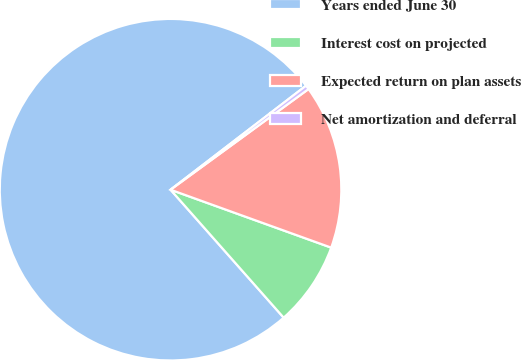Convert chart. <chart><loc_0><loc_0><loc_500><loc_500><pie_chart><fcel>Years ended June 30<fcel>Interest cost on projected<fcel>Expected return on plan assets<fcel>Net amortization and deferral<nl><fcel>76.1%<fcel>7.97%<fcel>15.54%<fcel>0.39%<nl></chart> 